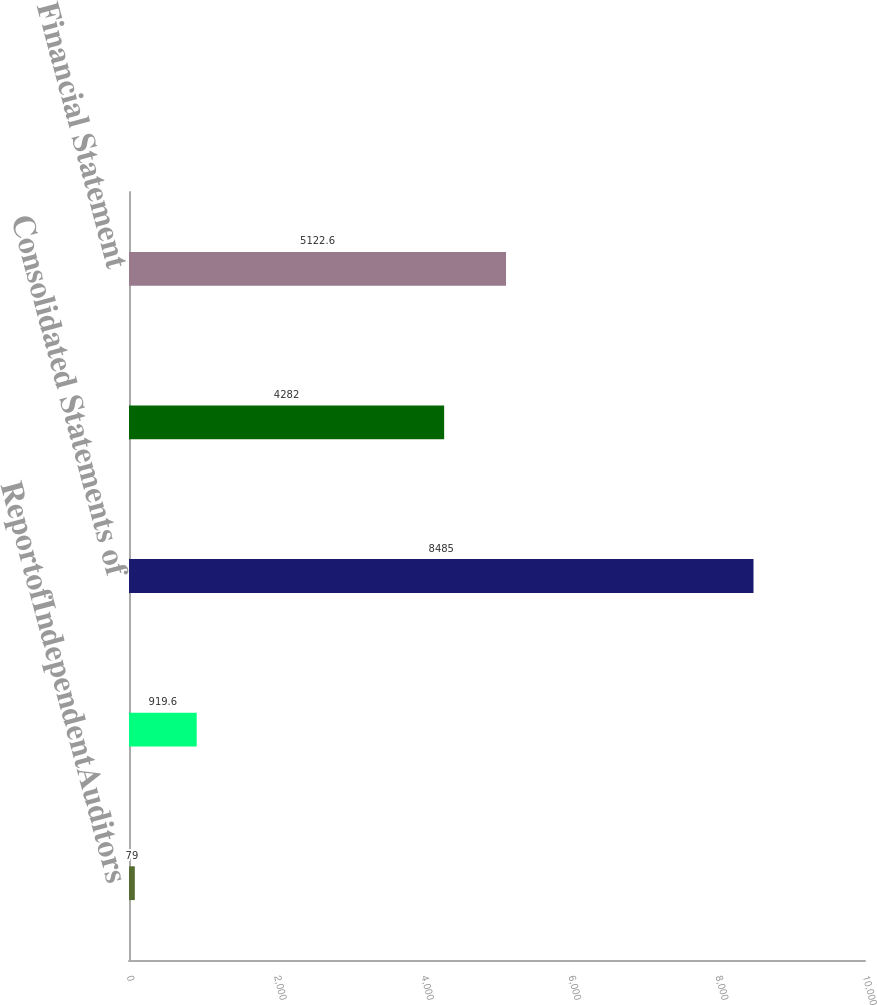<chart> <loc_0><loc_0><loc_500><loc_500><bar_chart><fcel>ReportofIndependentAuditors<fcel>Consolidated Balance Sheets as<fcel>Consolidated Statements of<fcel>Notes to Consolidated<fcel>Financial Statement<nl><fcel>79<fcel>919.6<fcel>8485<fcel>4282<fcel>5122.6<nl></chart> 